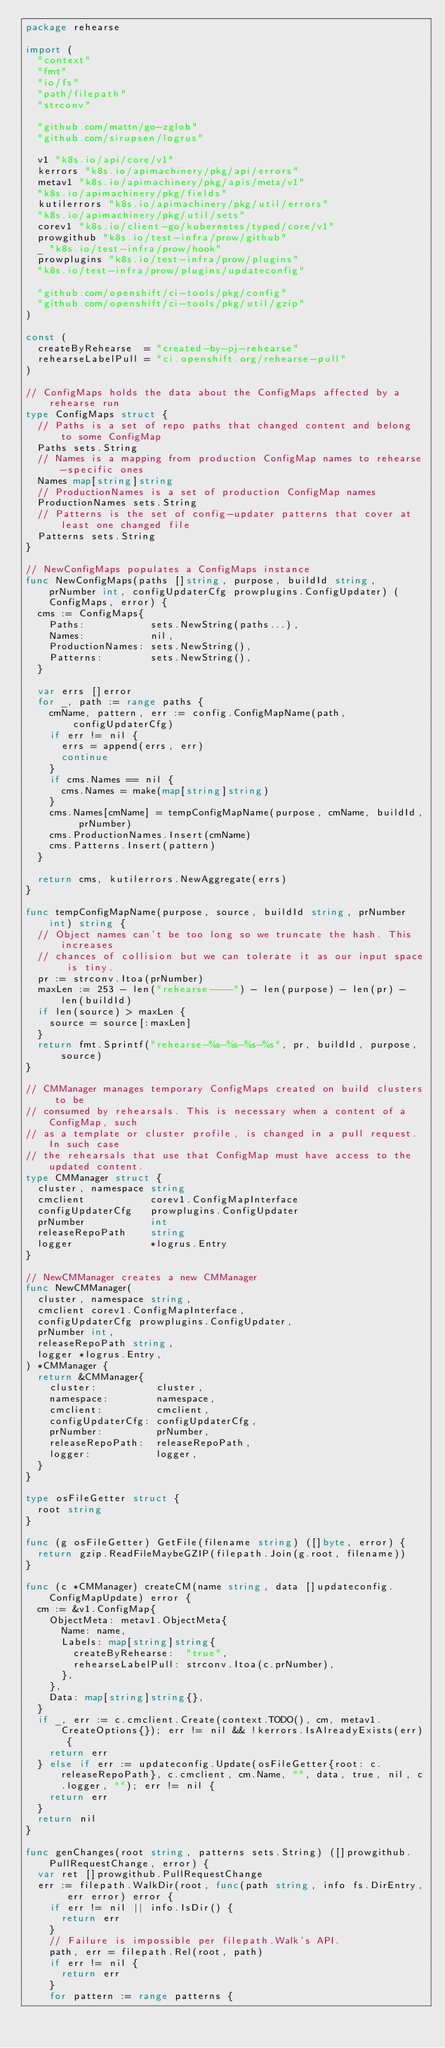Convert code to text. <code><loc_0><loc_0><loc_500><loc_500><_Go_>package rehearse

import (
	"context"
	"fmt"
	"io/fs"
	"path/filepath"
	"strconv"

	"github.com/mattn/go-zglob"
	"github.com/sirupsen/logrus"

	v1 "k8s.io/api/core/v1"
	kerrors "k8s.io/apimachinery/pkg/api/errors"
	metav1 "k8s.io/apimachinery/pkg/apis/meta/v1"
	"k8s.io/apimachinery/pkg/fields"
	kutilerrors "k8s.io/apimachinery/pkg/util/errors"
	"k8s.io/apimachinery/pkg/util/sets"
	corev1 "k8s.io/client-go/kubernetes/typed/core/v1"
	prowgithub "k8s.io/test-infra/prow/github"
	_ "k8s.io/test-infra/prow/hook"
	prowplugins "k8s.io/test-infra/prow/plugins"
	"k8s.io/test-infra/prow/plugins/updateconfig"

	"github.com/openshift/ci-tools/pkg/config"
	"github.com/openshift/ci-tools/pkg/util/gzip"
)

const (
	createByRehearse  = "created-by-pj-rehearse"
	rehearseLabelPull = "ci.openshift.org/rehearse-pull"
)

// ConfigMaps holds the data about the ConfigMaps affected by a rehearse run
type ConfigMaps struct {
	// Paths is a set of repo paths that changed content and belong to some ConfigMap
	Paths sets.String
	// Names is a mapping from production ConfigMap names to rehearse-specific ones
	Names map[string]string
	// ProductionNames is a set of production ConfigMap names
	ProductionNames sets.String
	// Patterns is the set of config-updater patterns that cover at least one changed file
	Patterns sets.String
}

// NewConfigMaps populates a ConfigMaps instance
func NewConfigMaps(paths []string, purpose, buildId string, prNumber int, configUpdaterCfg prowplugins.ConfigUpdater) (ConfigMaps, error) {
	cms := ConfigMaps{
		Paths:           sets.NewString(paths...),
		Names:           nil,
		ProductionNames: sets.NewString(),
		Patterns:        sets.NewString(),
	}

	var errs []error
	for _, path := range paths {
		cmName, pattern, err := config.ConfigMapName(path, configUpdaterCfg)
		if err != nil {
			errs = append(errs, err)
			continue
		}
		if cms.Names == nil {
			cms.Names = make(map[string]string)
		}
		cms.Names[cmName] = tempConfigMapName(purpose, cmName, buildId, prNumber)
		cms.ProductionNames.Insert(cmName)
		cms.Patterns.Insert(pattern)
	}

	return cms, kutilerrors.NewAggregate(errs)
}

func tempConfigMapName(purpose, source, buildId string, prNumber int) string {
	// Object names can't be too long so we truncate the hash. This increases
	// chances of collision but we can tolerate it as our input space is tiny.
	pr := strconv.Itoa(prNumber)
	maxLen := 253 - len("rehearse----") - len(purpose) - len(pr) - len(buildId)
	if len(source) > maxLen {
		source = source[:maxLen]
	}
	return fmt.Sprintf("rehearse-%s-%s-%s-%s", pr, buildId, purpose, source)
}

// CMManager manages temporary ConfigMaps created on build clusters to be
// consumed by rehearsals. This is necessary when a content of a ConfigMap, such
// as a template or cluster profile, is changed in a pull request. In such case
// the rehearsals that use that ConfigMap must have access to the updated content.
type CMManager struct {
	cluster, namespace string
	cmclient           corev1.ConfigMapInterface
	configUpdaterCfg   prowplugins.ConfigUpdater
	prNumber           int
	releaseRepoPath    string
	logger             *logrus.Entry
}

// NewCMManager creates a new CMManager
func NewCMManager(
	cluster, namespace string,
	cmclient corev1.ConfigMapInterface,
	configUpdaterCfg prowplugins.ConfigUpdater,
	prNumber int,
	releaseRepoPath string,
	logger *logrus.Entry,
) *CMManager {
	return &CMManager{
		cluster:          cluster,
		namespace:        namespace,
		cmclient:         cmclient,
		configUpdaterCfg: configUpdaterCfg,
		prNumber:         prNumber,
		releaseRepoPath:  releaseRepoPath,
		logger:           logger,
	}
}

type osFileGetter struct {
	root string
}

func (g osFileGetter) GetFile(filename string) ([]byte, error) {
	return gzip.ReadFileMaybeGZIP(filepath.Join(g.root, filename))
}

func (c *CMManager) createCM(name string, data []updateconfig.ConfigMapUpdate) error {
	cm := &v1.ConfigMap{
		ObjectMeta: metav1.ObjectMeta{
			Name: name,
			Labels: map[string]string{
				createByRehearse:  "true",
				rehearseLabelPull: strconv.Itoa(c.prNumber),
			},
		},
		Data: map[string]string{},
	}
	if _, err := c.cmclient.Create(context.TODO(), cm, metav1.CreateOptions{}); err != nil && !kerrors.IsAlreadyExists(err) {
		return err
	} else if err := updateconfig.Update(osFileGetter{root: c.releaseRepoPath}, c.cmclient, cm.Name, "", data, true, nil, c.logger, ""); err != nil {
		return err
	}
	return nil
}

func genChanges(root string, patterns sets.String) ([]prowgithub.PullRequestChange, error) {
	var ret []prowgithub.PullRequestChange
	err := filepath.WalkDir(root, func(path string, info fs.DirEntry, err error) error {
		if err != nil || info.IsDir() {
			return err
		}
		// Failure is impossible per filepath.Walk's API.
		path, err = filepath.Rel(root, path)
		if err != nil {
			return err
		}
		for pattern := range patterns {</code> 